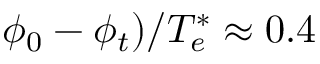Convert formula to latex. <formula><loc_0><loc_0><loc_500><loc_500>\phi _ { 0 } - \phi _ { t } ) / T _ { e } ^ { * } \approx 0 . 4</formula> 